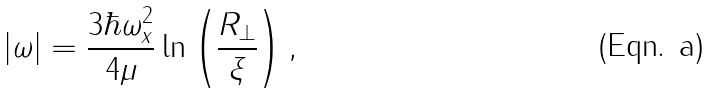Convert formula to latex. <formula><loc_0><loc_0><loc_500><loc_500>| \omega | = \frac { 3 \hbar { \omega } _ { x } ^ { 2 } } { 4 \mu } \ln \left ( \frac { R _ { \bot } } { \xi } \right ) ,</formula> 